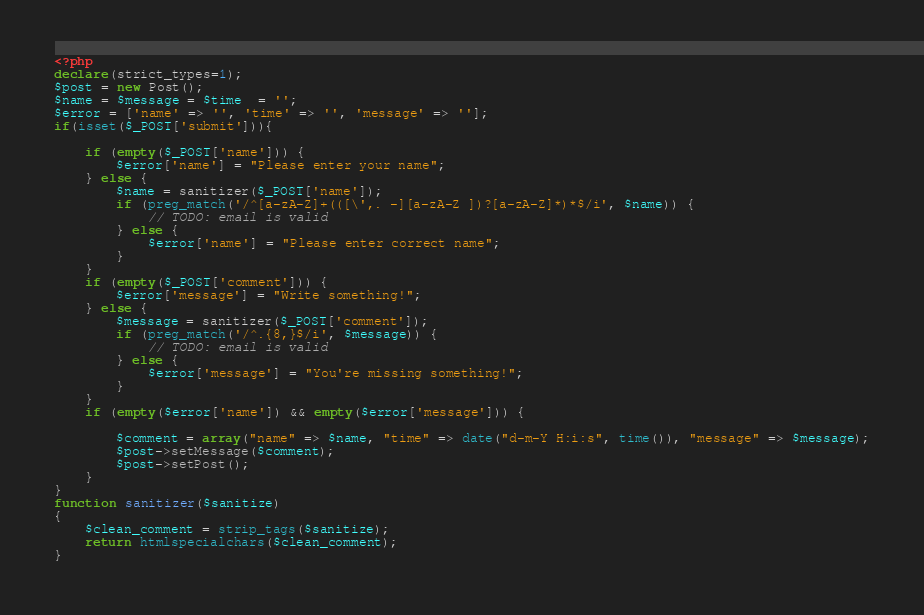<code> <loc_0><loc_0><loc_500><loc_500><_PHP_><?php
declare(strict_types=1);
$post = new Post();
$name = $message = $time  = '';
$error = ['name' => '', 'time' => '', 'message' => ''];
if(isset($_POST['submit'])){

    if (empty($_POST['name'])) {
        $error['name'] = "Please enter your name";
    } else {
        $name = sanitizer($_POST['name']);
        if (preg_match('/^[a-zA-Z]+(([\',. -][a-zA-Z ])?[a-zA-Z]*)*$/i', $name)) {
            // TODO: email is valid
        } else {
            $error['name'] = "Please enter correct name";
        }
    }
    if (empty($_POST['comment'])) {
        $error['message'] = "Write something!";
    } else {
        $message = sanitizer($_POST['comment']);
        if (preg_match('/^.{8,}$/i', $message)) {
            // TODO: email is valid
        } else {
            $error['message'] = "You're missing something!";
        }
    }
    if (empty($error['name']) && empty($error['message'])) {

        $comment = array("name" => $name, "time" => date("d-m-Y H:i:s", time()), "message" => $message);
        $post->setMessage($comment);
        $post->setPost();
    }
}
function sanitizer($sanitize)
{
    $clean_comment = strip_tags($sanitize);
    return htmlspecialchars($clean_comment);
}</code> 